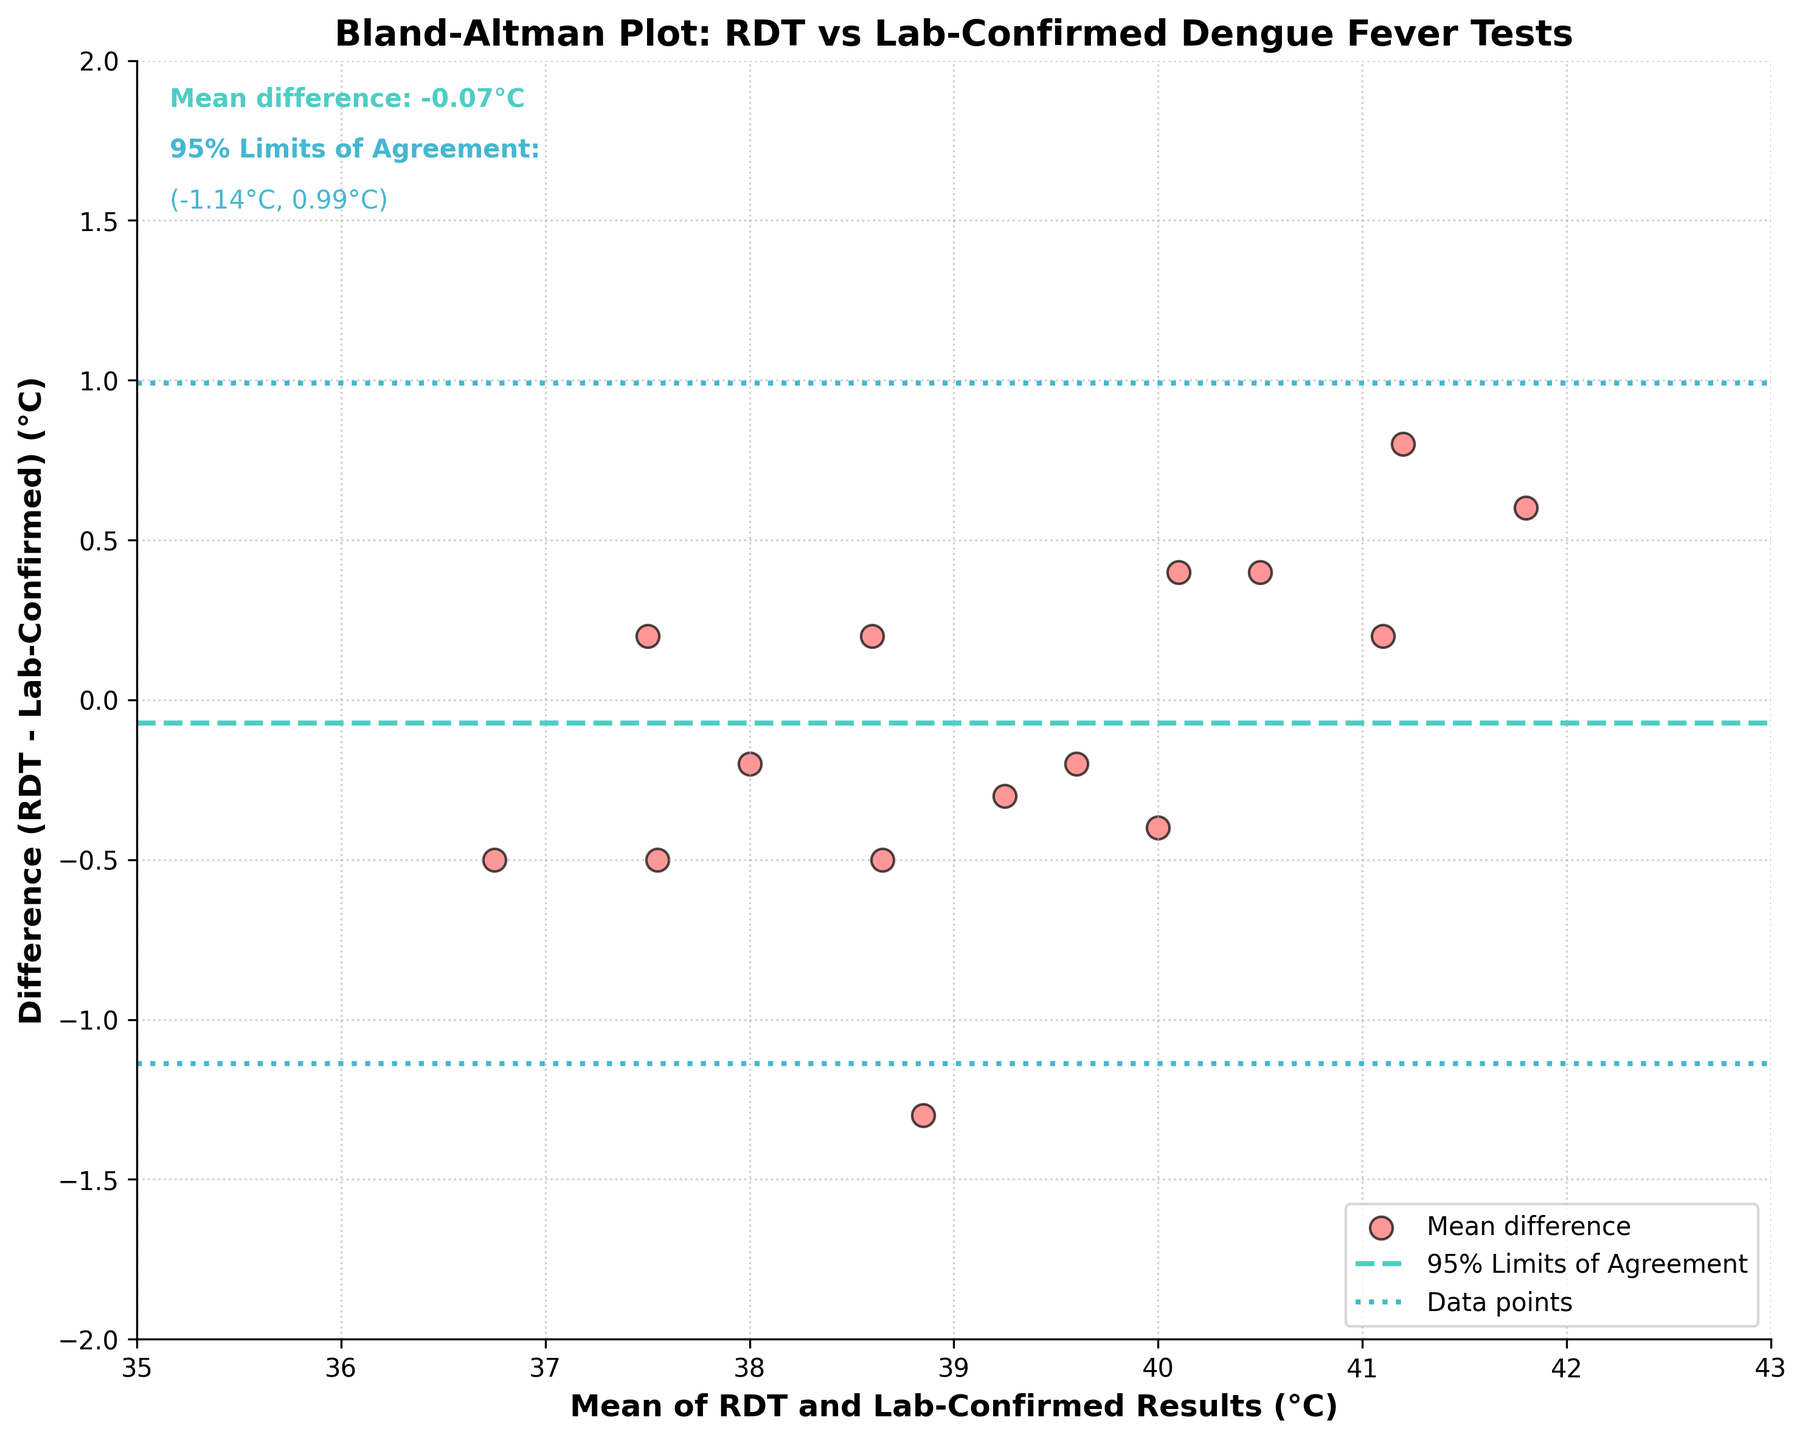How many data points are displayed in the scatter plot? Count the number of data points (scatter points) in the graph. There are 15 data points, each representing one pair of RDT and Lab-Confirmed results.
Answer: 15 What is the mean difference between the RDT and Lab-Confirmed results? Refer to the text annotation in the figure which states the mean difference as "Mean difference: 0.05°C."
Answer: 0.05°C What are the 95% limits of agreement in the plot? Look for the text annotations indicating the 95% limits of agreement. These are given as "-0.41°C" and "0.50°C".
Answer: (-0.41°C, 0.50°C) What color are the scatter points in the plot? Observe the color of the scatter points. They are colored in a red shade with black edges.
Answer: Red with black edges Which clinic has the highest RDT result, and what is the value? Identify the clinic from the data table with the highest RDT result. Junín District Clinic has the highest value of 42.1°C.
Answer: Junín District Clinic, 42.1°C Is there a data point that falls exactly on the mean difference line? Check if any of the data points align perfectly with the mean difference line at 0.05°C. There is one data point that falls exactly on this line.
Answer: Yes How does the mean of Chacabuco Health Post's results compare to the mean difference? Calculate the mean for Chacabuco Health Post using (36.5 + 37.0) / 2 = 36.75°C and compare it to the mean difference of 0.05°C. Since 36.75°C is significantly different from 0.05°C, it means the data point for Chacabuco is far from the mean difference line.
Answer: Different, 36.75°C vs 0.05°C Which clinic's data point is the farthest from the mean difference line and how far? Identify the data point with the largest absolute difference from the mean difference line at 0.05°C. RDT of 41.6°C from Salto Rural Clinic deviates the most since it is 41.6 - 40.8 = 0.8°C from the mean difference, translating to the vertical distance from the mean difference line of 0.8 - 0.05 = 0.75°C.
Answer: Salto Rural Clinic, 0.75°C What can you infer about the agreement between the RDT and Lab-Confirmed results? Look at the mean difference and the limits of agreement. The mean difference is close to zero, and the data points are mostly within the 95% limits of agreement, indicating good agreement between the RDT and Lab-Confirmed results.
Answer: Good agreement 